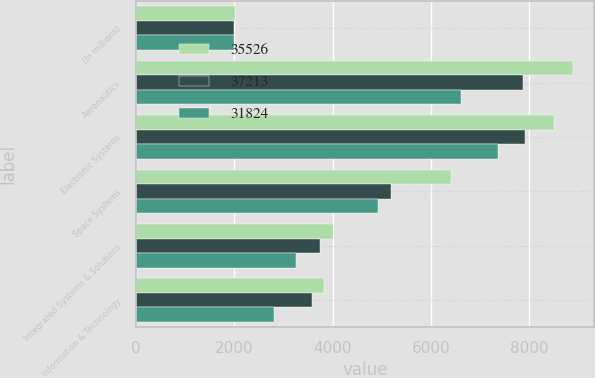<chart> <loc_0><loc_0><loc_500><loc_500><stacked_bar_chart><ecel><fcel>(In millions)<fcel>Aeronautics<fcel>Electronic Systems<fcel>Space Systems<fcel>Integrated Systems & Solutions<fcel>Information & Technology<nl><fcel>35526<fcel>2005<fcel>8883<fcel>8504<fcel>6409<fcel>4016<fcel>3816<nl><fcel>37213<fcel>2004<fcel>7876<fcel>7909<fcel>5180<fcel>3742<fcel>3589<nl><fcel>31824<fcel>2003<fcel>6613<fcel>7363<fcel>4928<fcel>3252<fcel>2799<nl></chart> 